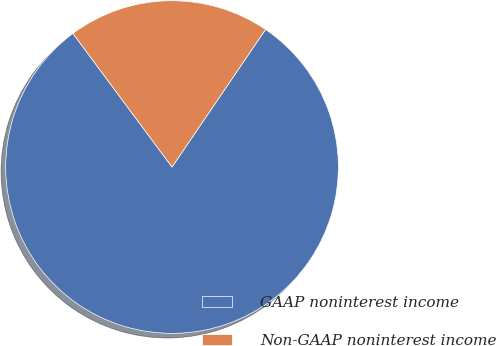<chart> <loc_0><loc_0><loc_500><loc_500><pie_chart><fcel>GAAP noninterest income<fcel>Non-GAAP noninterest income<nl><fcel>80.34%<fcel>19.66%<nl></chart> 